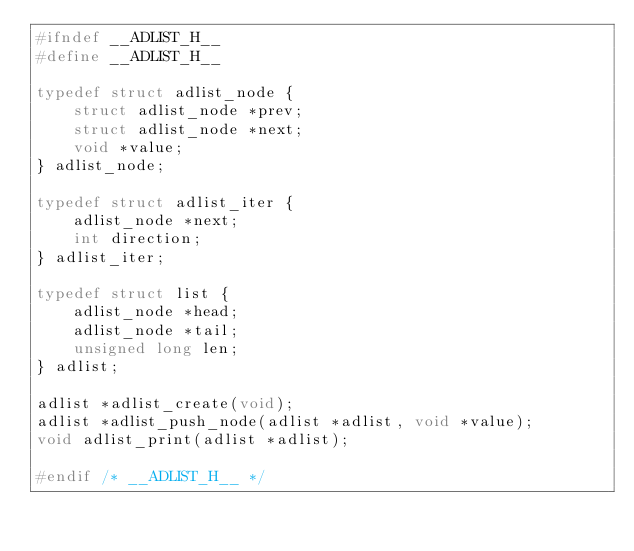Convert code to text. <code><loc_0><loc_0><loc_500><loc_500><_C_>#ifndef __ADLIST_H__
#define __ADLIST_H__

typedef struct adlist_node {
	struct adlist_node *prev;
	struct adlist_node *next;
	void *value;
} adlist_node;

typedef struct adlist_iter {
	adlist_node *next;
	int direction;
} adlist_iter;

typedef struct list {
	adlist_node *head;
	adlist_node *tail;
	unsigned long len;
} adlist;

adlist *adlist_create(void);
adlist *adlist_push_node(adlist *adlist, void *value);
void adlist_print(adlist *adlist);

#endif /* __ADLIST_H__ */
</code> 